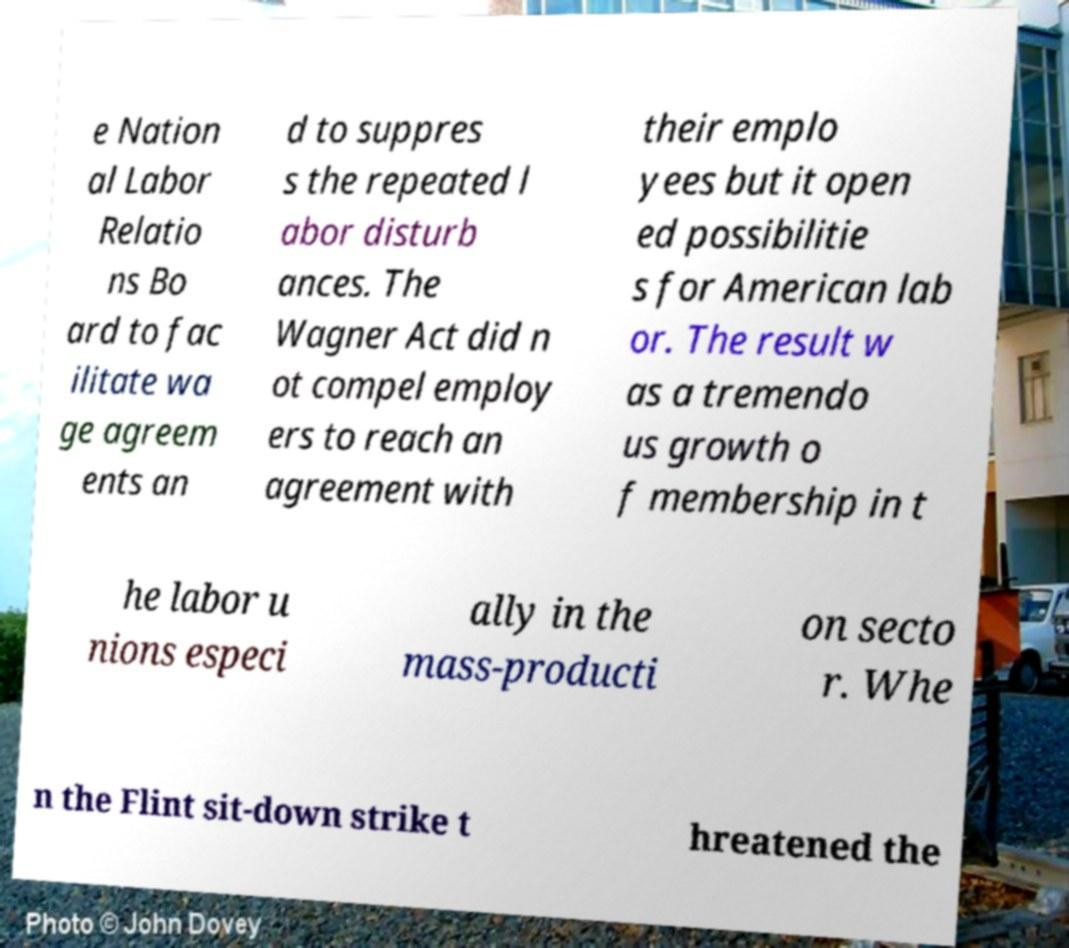There's text embedded in this image that I need extracted. Can you transcribe it verbatim? e Nation al Labor Relatio ns Bo ard to fac ilitate wa ge agreem ents an d to suppres s the repeated l abor disturb ances. The Wagner Act did n ot compel employ ers to reach an agreement with their emplo yees but it open ed possibilitie s for American lab or. The result w as a tremendo us growth o f membership in t he labor u nions especi ally in the mass-producti on secto r. Whe n the Flint sit-down strike t hreatened the 